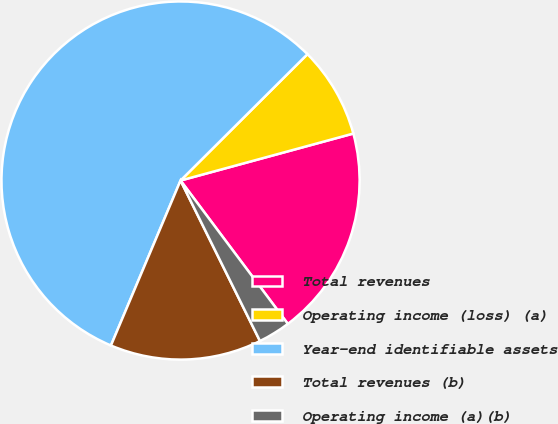Convert chart. <chart><loc_0><loc_0><loc_500><loc_500><pie_chart><fcel>Total revenues<fcel>Operating income (loss) (a)<fcel>Year-end identifiable assets<fcel>Total revenues (b)<fcel>Operating income (a)(b)<nl><fcel>19.0%<fcel>8.24%<fcel>56.18%<fcel>13.67%<fcel>2.91%<nl></chart> 